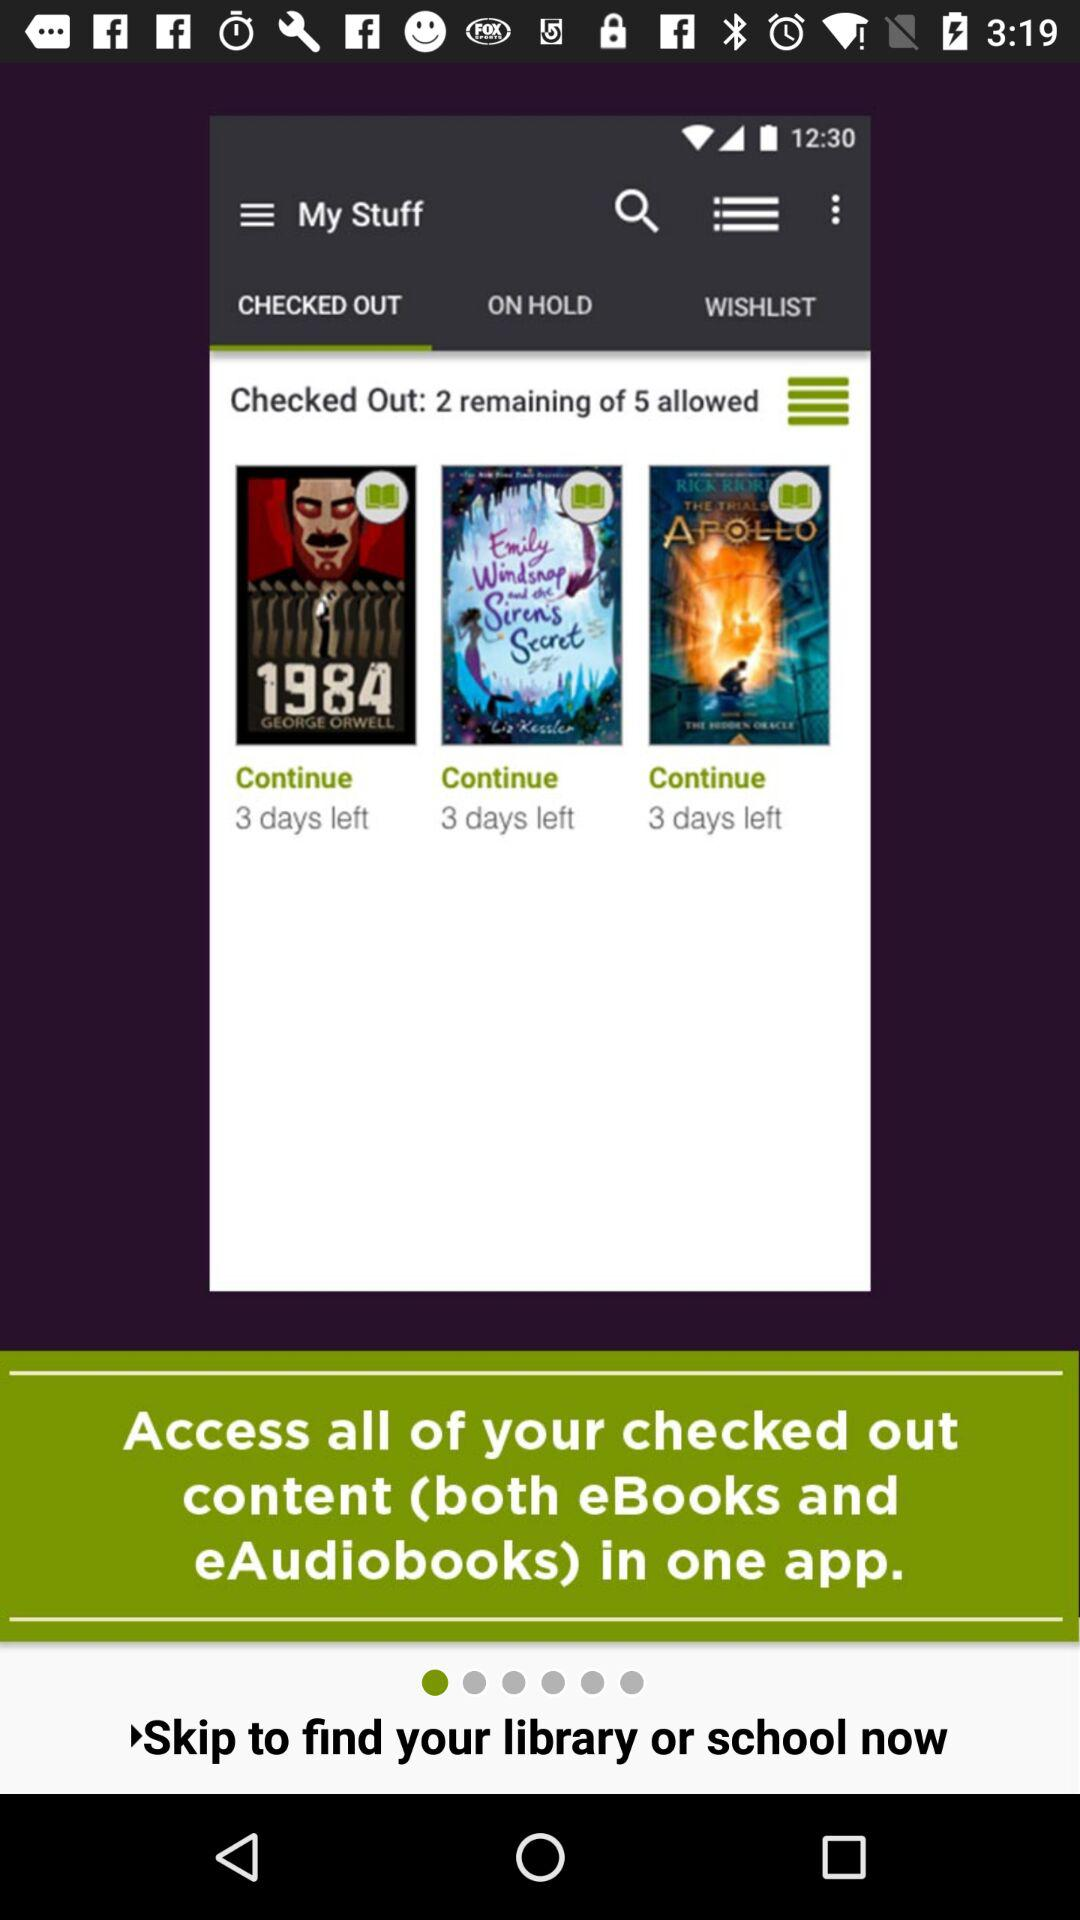Which tab is selected? The selected tab is "CHECKED OUT". 